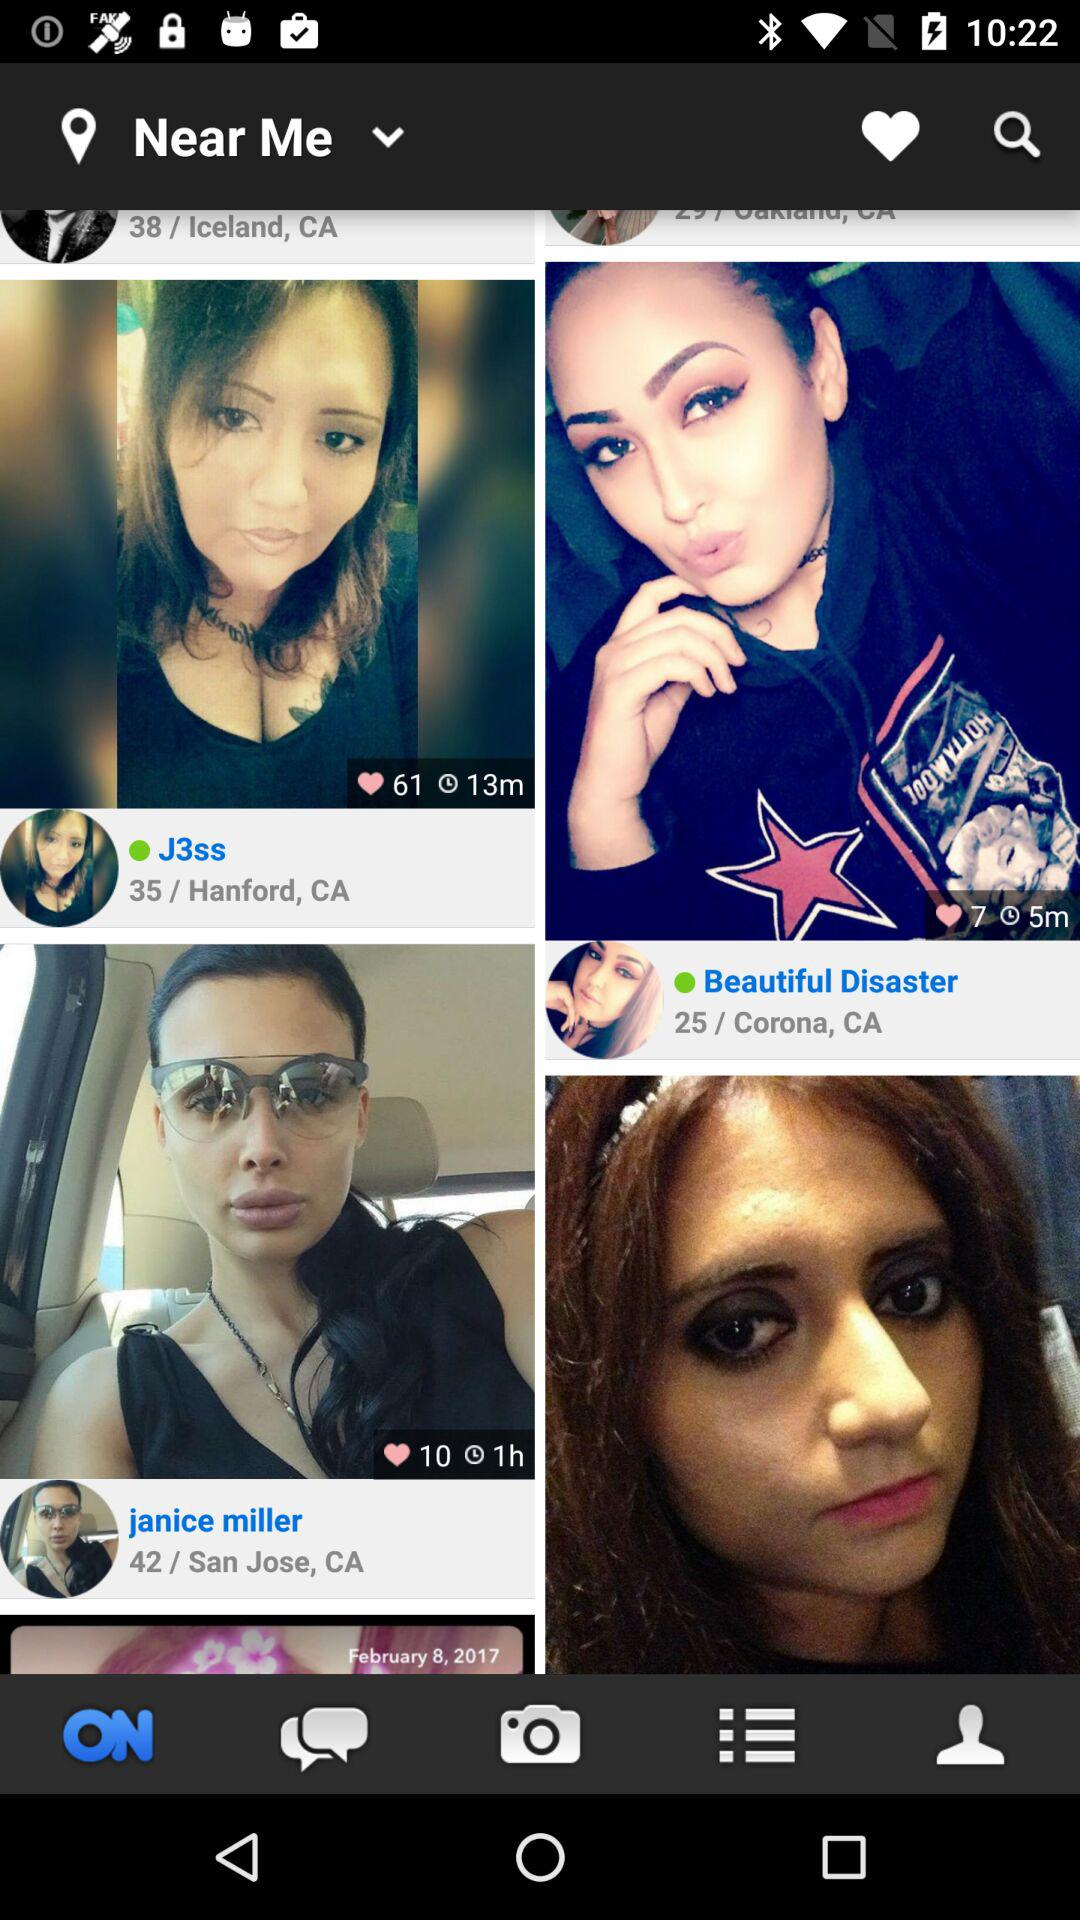How many people like Janice Miller? There are 10 people who like Janice Miller. 